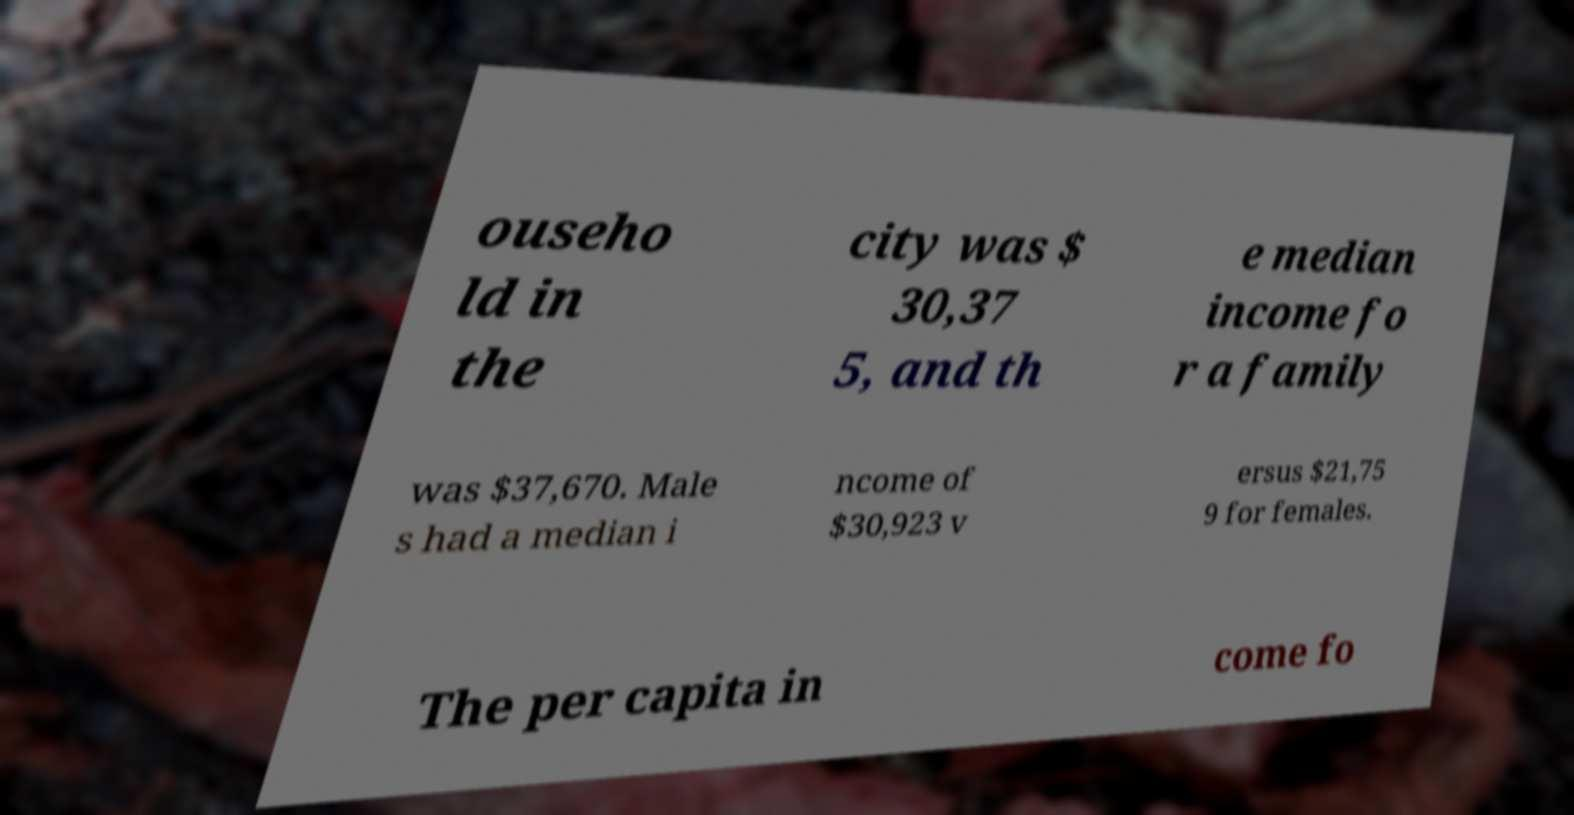What messages or text are displayed in this image? I need them in a readable, typed format. ouseho ld in the city was $ 30,37 5, and th e median income fo r a family was $37,670. Male s had a median i ncome of $30,923 v ersus $21,75 9 for females. The per capita in come fo 